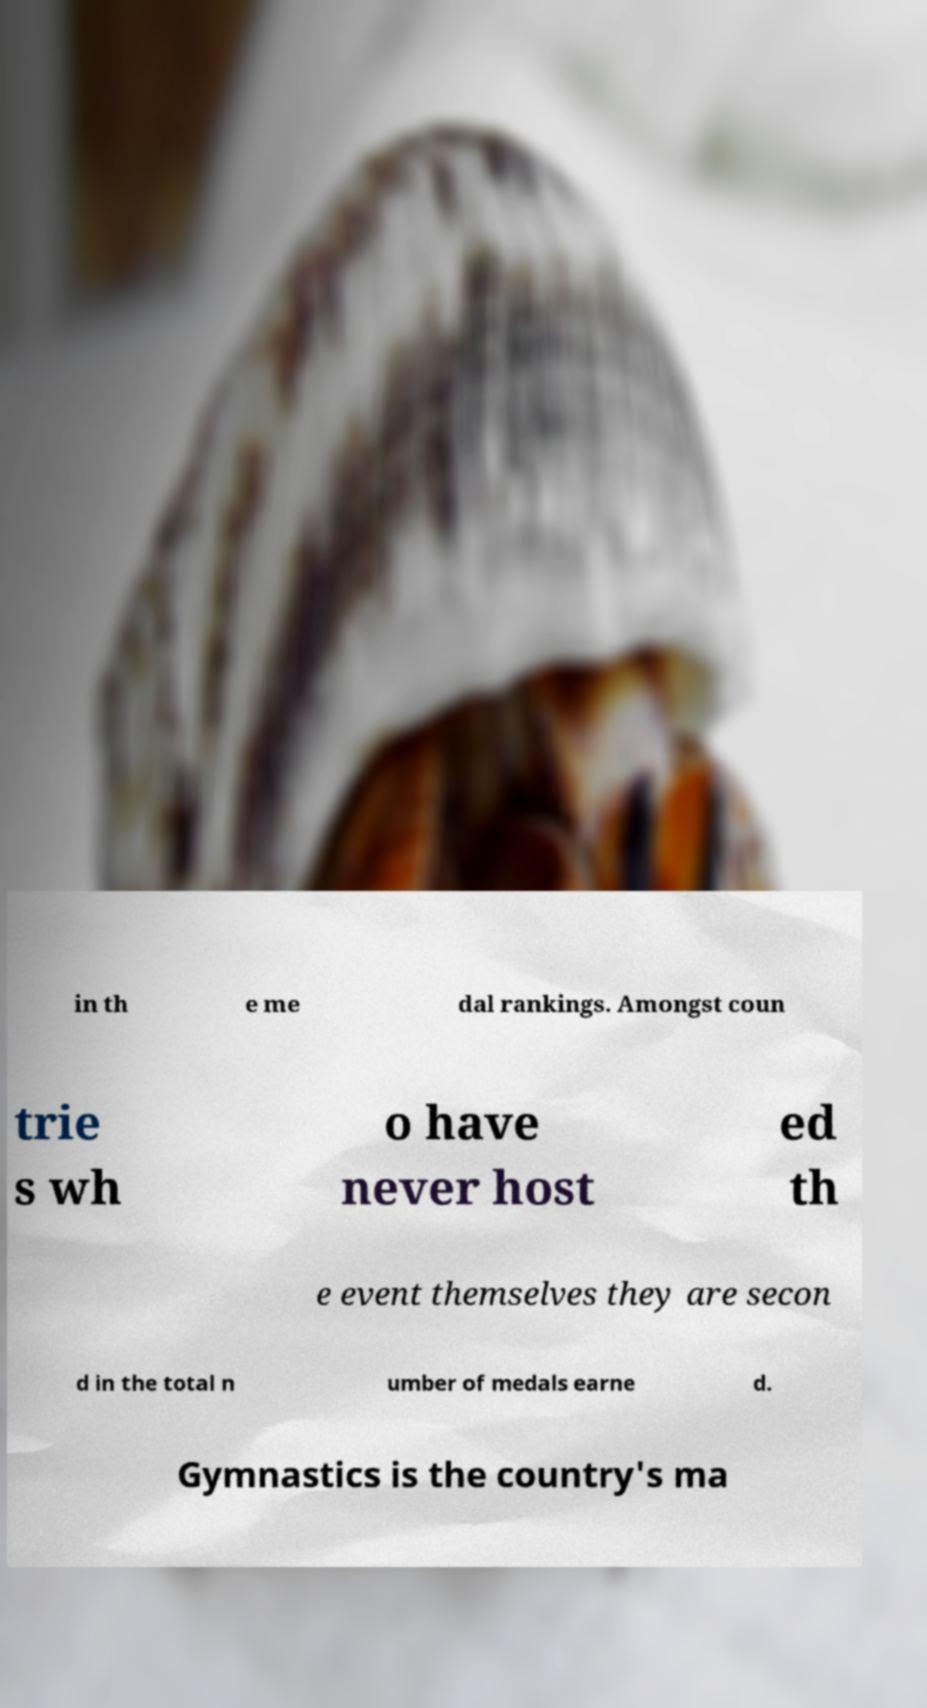Can you read and provide the text displayed in the image?This photo seems to have some interesting text. Can you extract and type it out for me? in th e me dal rankings. Amongst coun trie s wh o have never host ed th e event themselves they are secon d in the total n umber of medals earne d. Gymnastics is the country's ma 